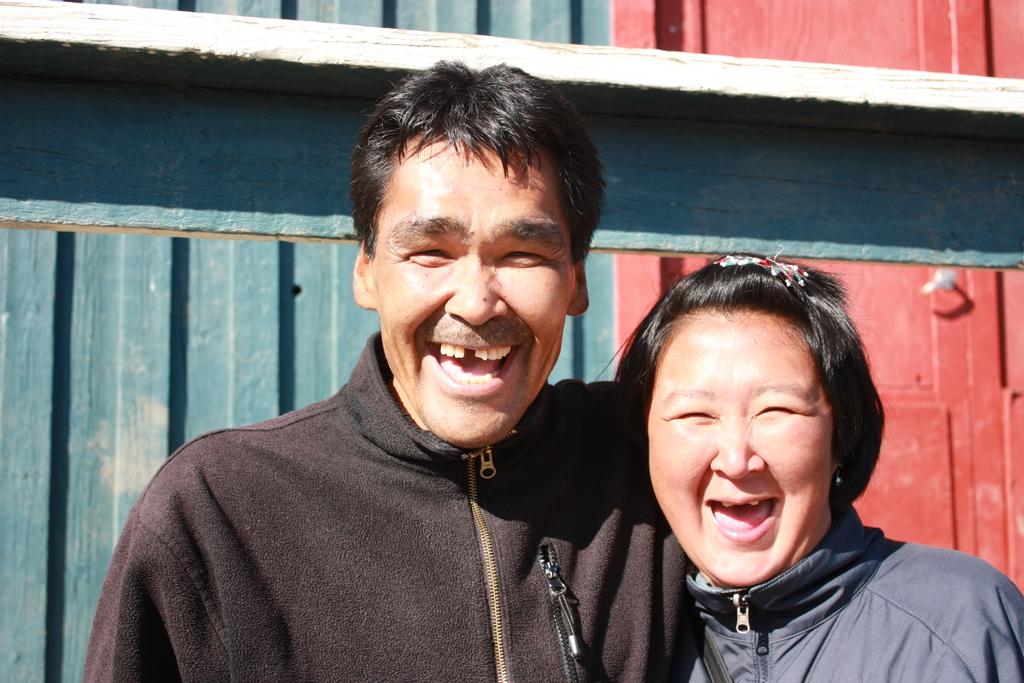How many people are present in the image? There are two people in the image. What is the facial expression of the people in the image? The people are smiling. What can be seen in the background of the image? There is a wall in the background of the image. What type of pollution can be seen in the image? There is no pollution present in the image. Can you describe the basket in the image? There is no basket present in the image. 